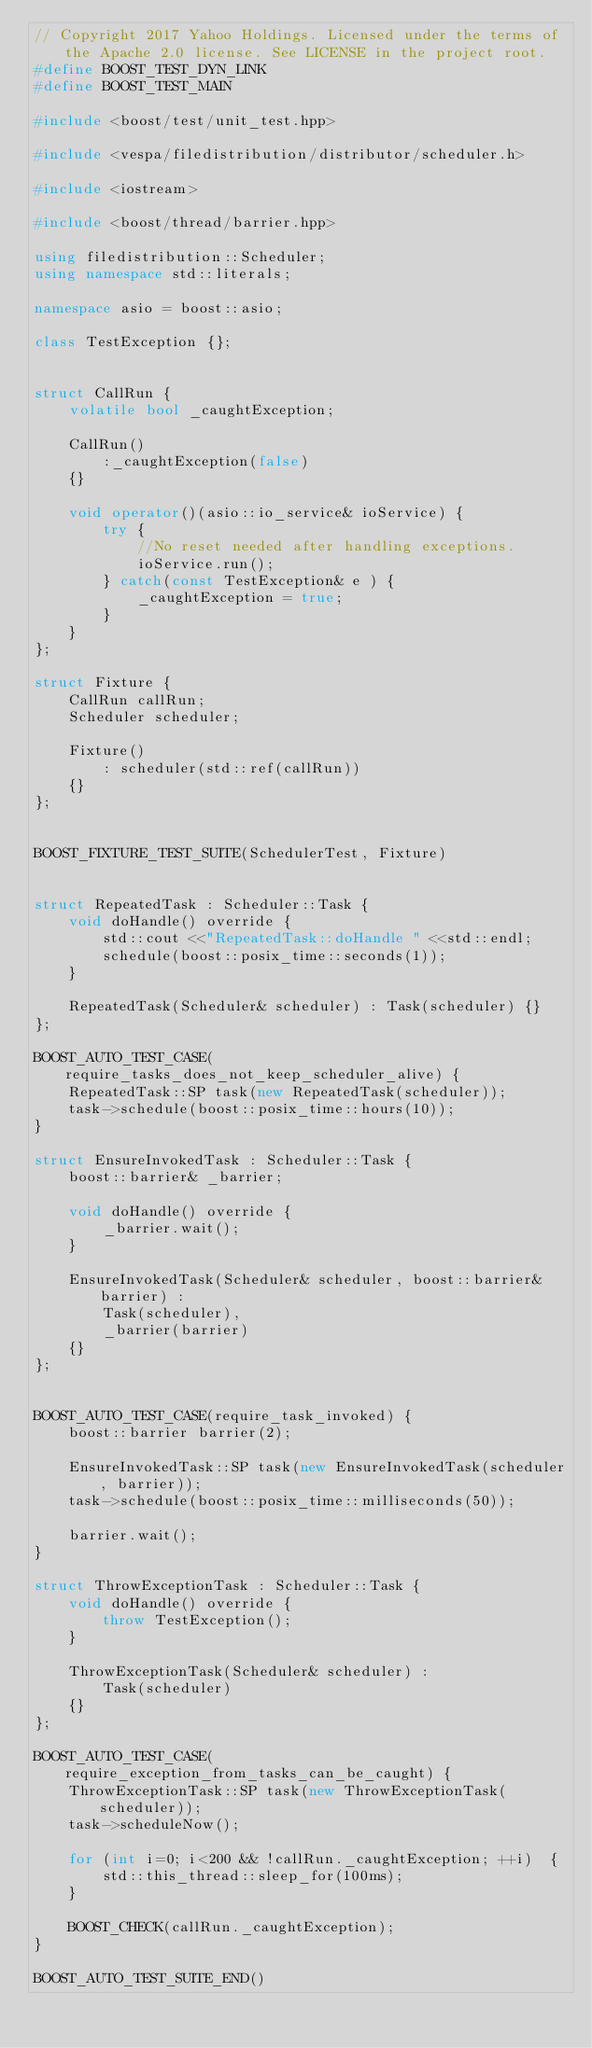Convert code to text. <code><loc_0><loc_0><loc_500><loc_500><_C++_>// Copyright 2017 Yahoo Holdings. Licensed under the terms of the Apache 2.0 license. See LICENSE in the project root.
#define BOOST_TEST_DYN_LINK
#define BOOST_TEST_MAIN

#include <boost/test/unit_test.hpp>

#include <vespa/filedistribution/distributor/scheduler.h>

#include <iostream>

#include <boost/thread/barrier.hpp>

using filedistribution::Scheduler;
using namespace std::literals;

namespace asio = boost::asio;

class TestException {};


struct CallRun {
    volatile bool _caughtException;

    CallRun()
        :_caughtException(false)
    {}

    void operator()(asio::io_service& ioService) {
        try {
            //No reset needed after handling exceptions.
            ioService.run();
        } catch(const TestException& e ) {
            _caughtException = true;
        }
    }
};

struct Fixture {
    CallRun callRun;
    Scheduler scheduler;

    Fixture()
        : scheduler(std::ref(callRun))
    {}
};


BOOST_FIXTURE_TEST_SUITE(SchedulerTest, Fixture)


struct RepeatedTask : Scheduler::Task {
    void doHandle() override {
        std::cout <<"RepeatedTask::doHandle " <<std::endl;
        schedule(boost::posix_time::seconds(1));
    }

    RepeatedTask(Scheduler& scheduler) : Task(scheduler) {}
};

BOOST_AUTO_TEST_CASE(require_tasks_does_not_keep_scheduler_alive) {
    RepeatedTask::SP task(new RepeatedTask(scheduler));
    task->schedule(boost::posix_time::hours(10));
}

struct EnsureInvokedTask : Scheduler::Task {
    boost::barrier& _barrier;

    void doHandle() override {
        _barrier.wait();
    }

    EnsureInvokedTask(Scheduler& scheduler, boost::barrier& barrier) :
        Task(scheduler),
        _barrier(barrier)
    {}
};


BOOST_AUTO_TEST_CASE(require_task_invoked) {
    boost::barrier barrier(2);

    EnsureInvokedTask::SP task(new EnsureInvokedTask(scheduler, barrier));
    task->schedule(boost::posix_time::milliseconds(50));

    barrier.wait();
}

struct ThrowExceptionTask : Scheduler::Task {
    void doHandle() override {
        throw TestException();
    }

    ThrowExceptionTask(Scheduler& scheduler) :
        Task(scheduler)
    {}
};

BOOST_AUTO_TEST_CASE(require_exception_from_tasks_can_be_caught) {
    ThrowExceptionTask::SP task(new ThrowExceptionTask(scheduler));
    task->scheduleNow();

    for (int i=0; i<200 && !callRun._caughtException; ++i)  {
        std::this_thread::sleep_for(100ms);
    }

    BOOST_CHECK(callRun._caughtException);
}

BOOST_AUTO_TEST_SUITE_END()
</code> 